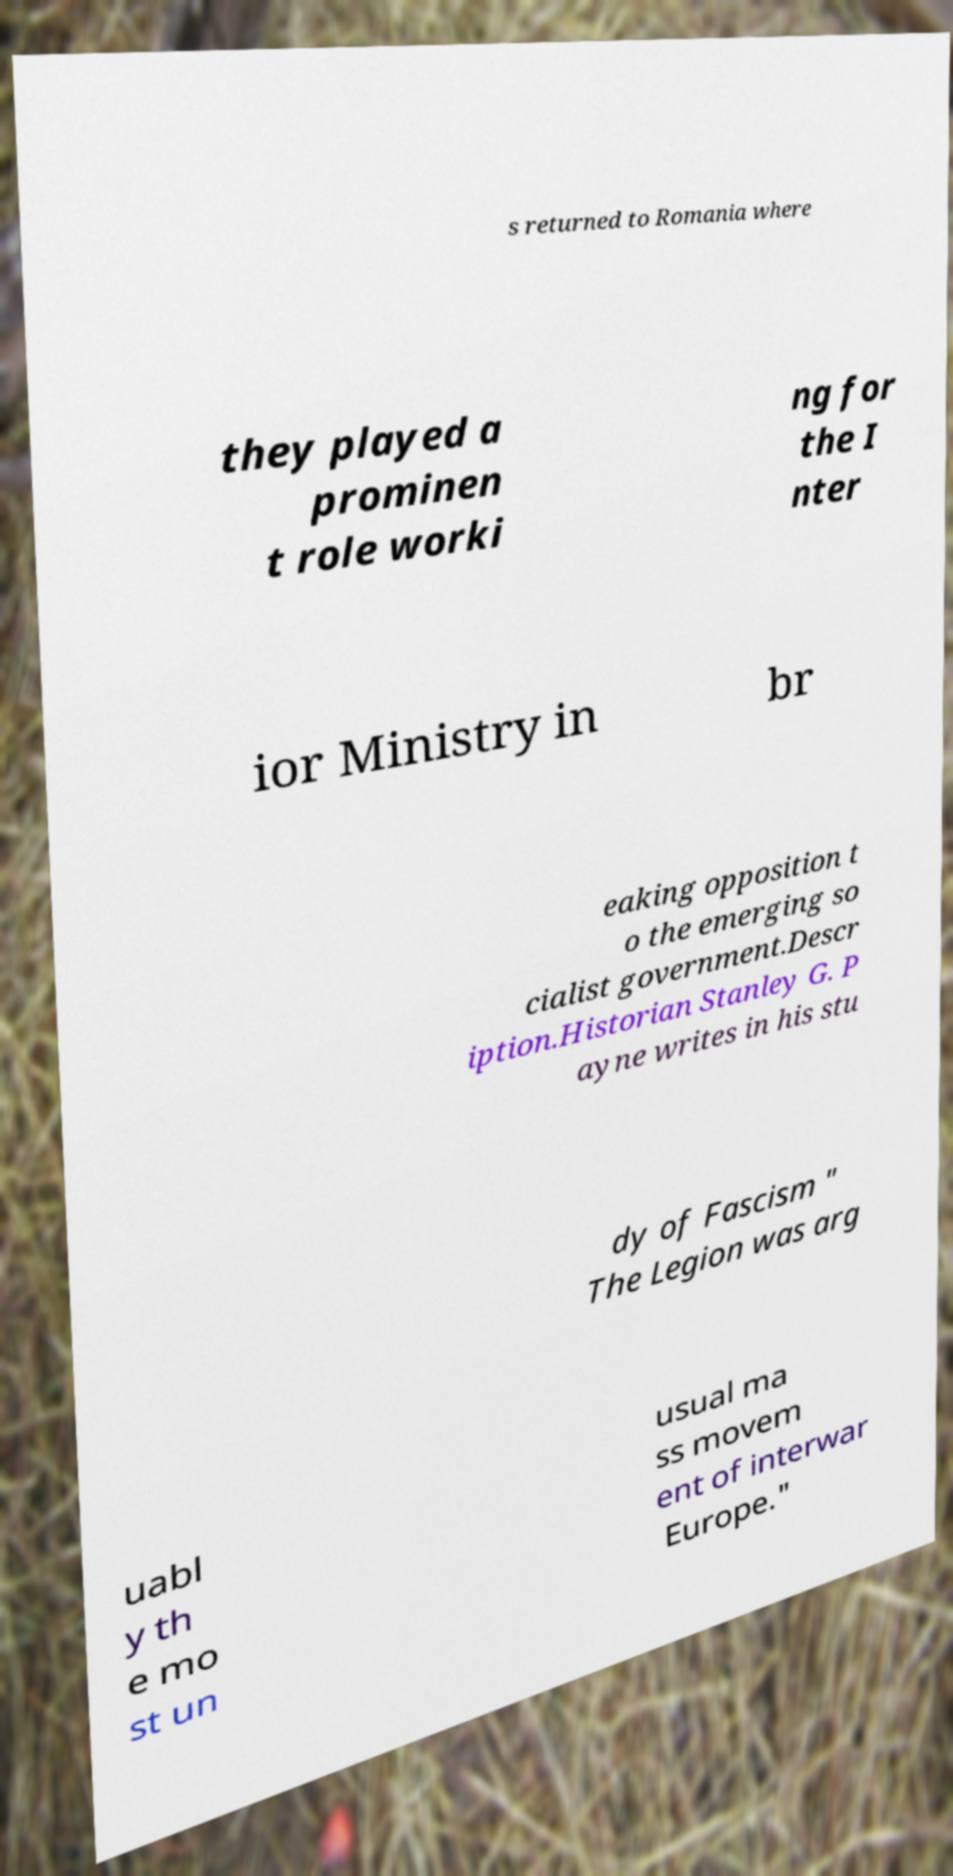What messages or text are displayed in this image? I need them in a readable, typed format. s returned to Romania where they played a prominen t role worki ng for the I nter ior Ministry in br eaking opposition t o the emerging so cialist government.Descr iption.Historian Stanley G. P ayne writes in his stu dy of Fascism " The Legion was arg uabl y th e mo st un usual ma ss movem ent of interwar Europe." 